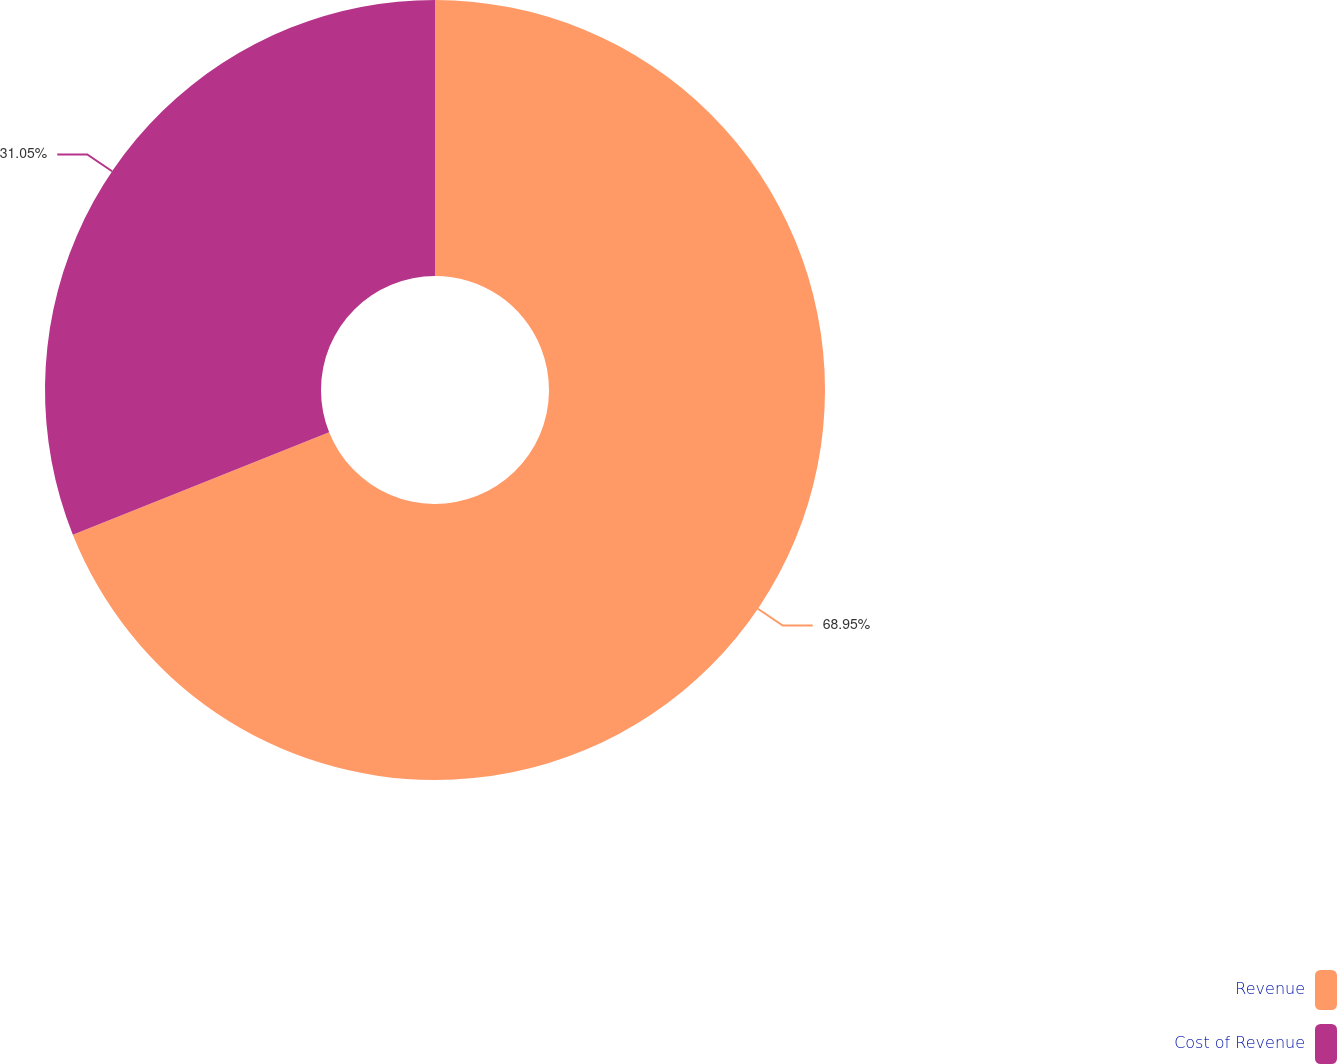Convert chart. <chart><loc_0><loc_0><loc_500><loc_500><pie_chart><fcel>Revenue<fcel>Cost of Revenue<nl><fcel>68.95%<fcel>31.05%<nl></chart> 